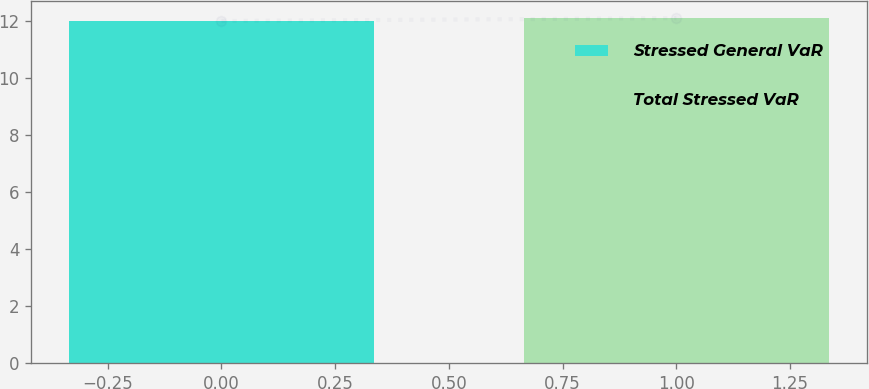<chart> <loc_0><loc_0><loc_500><loc_500><bar_chart><fcel>Stressed General VaR<fcel>Total Stressed VaR<nl><fcel>12<fcel>12.1<nl></chart> 